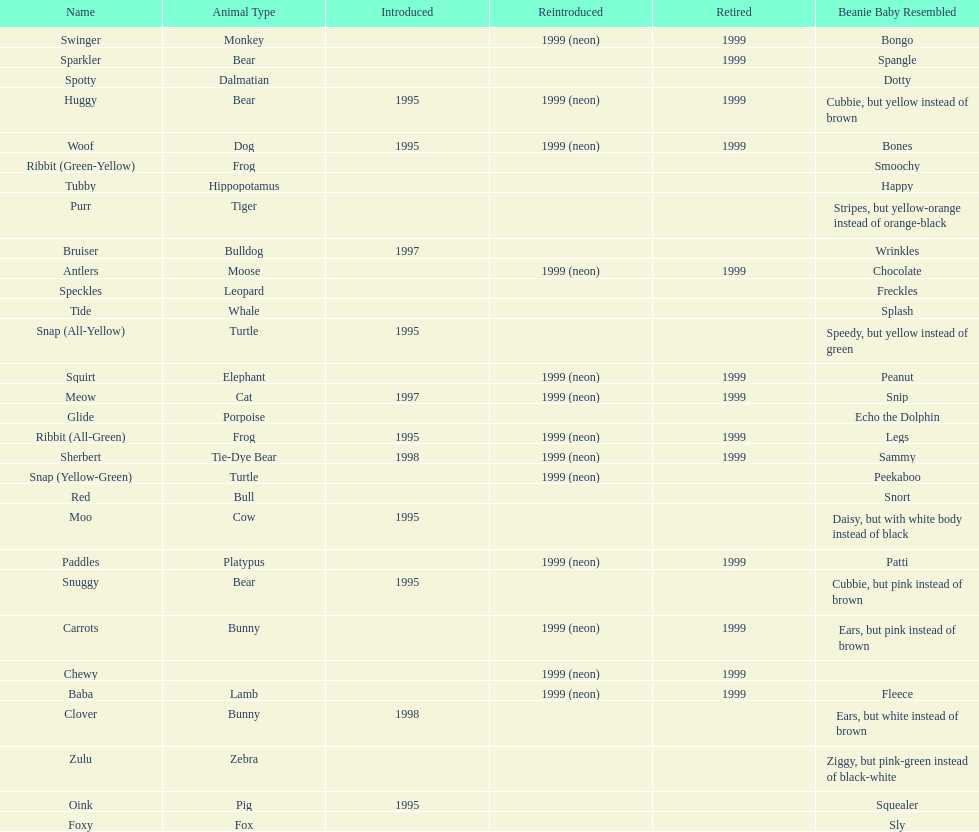What is the name of the pillow pal listed after clover? Foxy. 